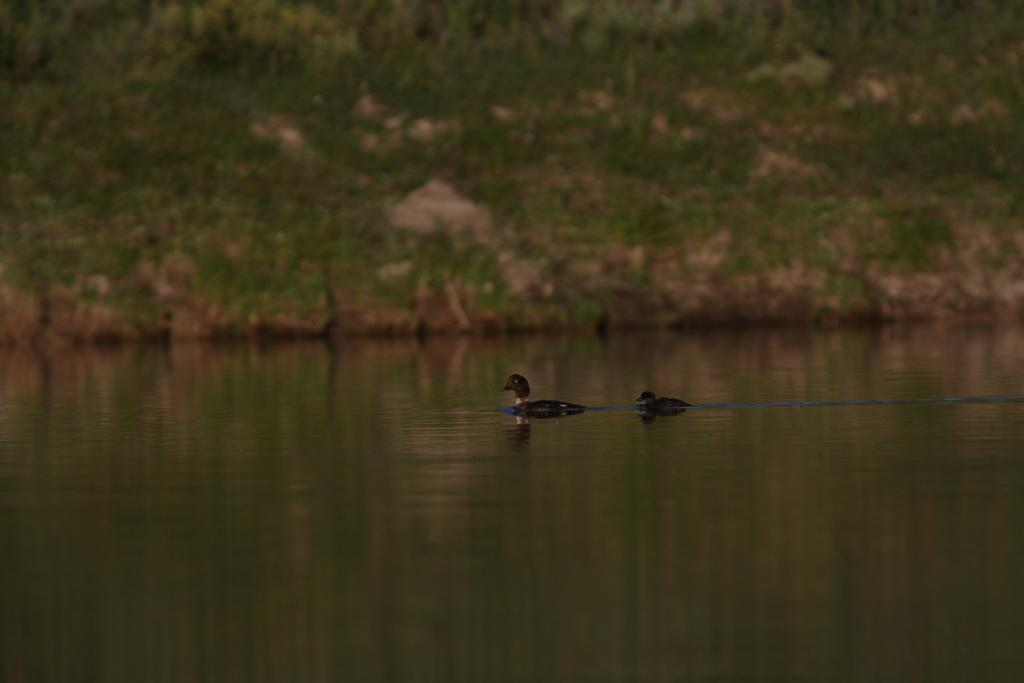What type of animals are in the image? There are ducks in the image. Where are the ducks located? The ducks are on the water. What can be seen in the background of the image? There are plants in the background of the image. What game are the ducks playing in the image? There is no indication in the image that the ducks are playing a game. What caused the sidewalk to appear in the image? There is no sidewalk present in the image. 